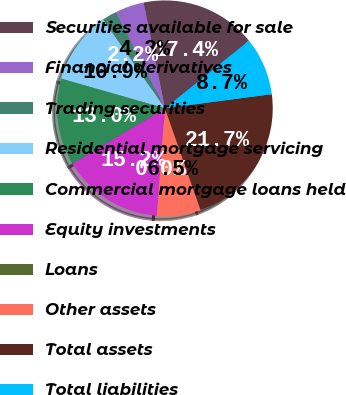Convert chart. <chart><loc_0><loc_0><loc_500><loc_500><pie_chart><fcel>Securities available for sale<fcel>Financial derivatives<fcel>Trading securities<fcel>Residential mortgage servicing<fcel>Commercial mortgage loans held<fcel>Equity investments<fcel>Loans<fcel>Other assets<fcel>Total assets<fcel>Total liabilities<nl><fcel>17.38%<fcel>4.35%<fcel>2.18%<fcel>10.87%<fcel>13.04%<fcel>15.21%<fcel>0.01%<fcel>6.53%<fcel>21.73%<fcel>8.7%<nl></chart> 